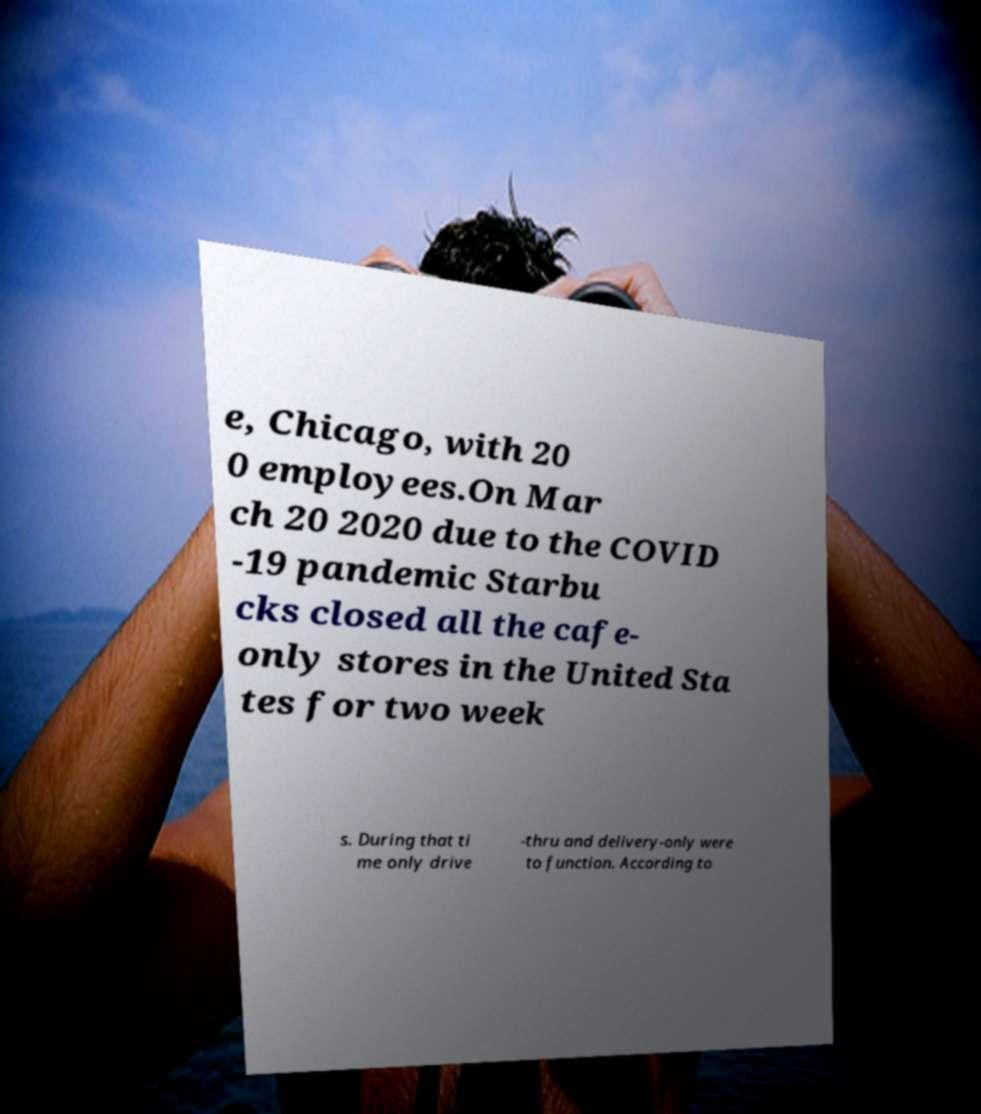For documentation purposes, I need the text within this image transcribed. Could you provide that? e, Chicago, with 20 0 employees.On Mar ch 20 2020 due to the COVID -19 pandemic Starbu cks closed all the cafe- only stores in the United Sta tes for two week s. During that ti me only drive -thru and delivery-only were to function. According to 